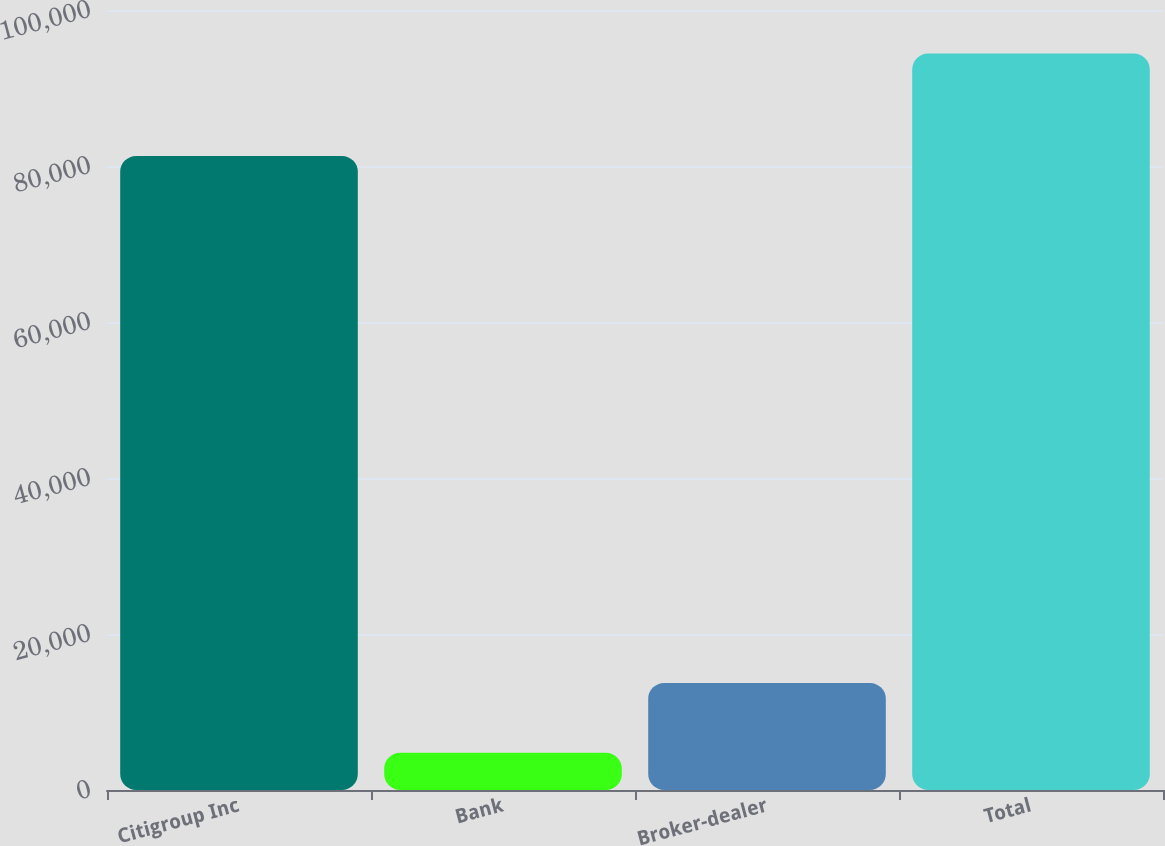<chart> <loc_0><loc_0><loc_500><loc_500><bar_chart><fcel>Citigroup Inc<fcel>Bank<fcel>Broker-dealer<fcel>Total<nl><fcel>81295<fcel>4764<fcel>13728.4<fcel>94408<nl></chart> 